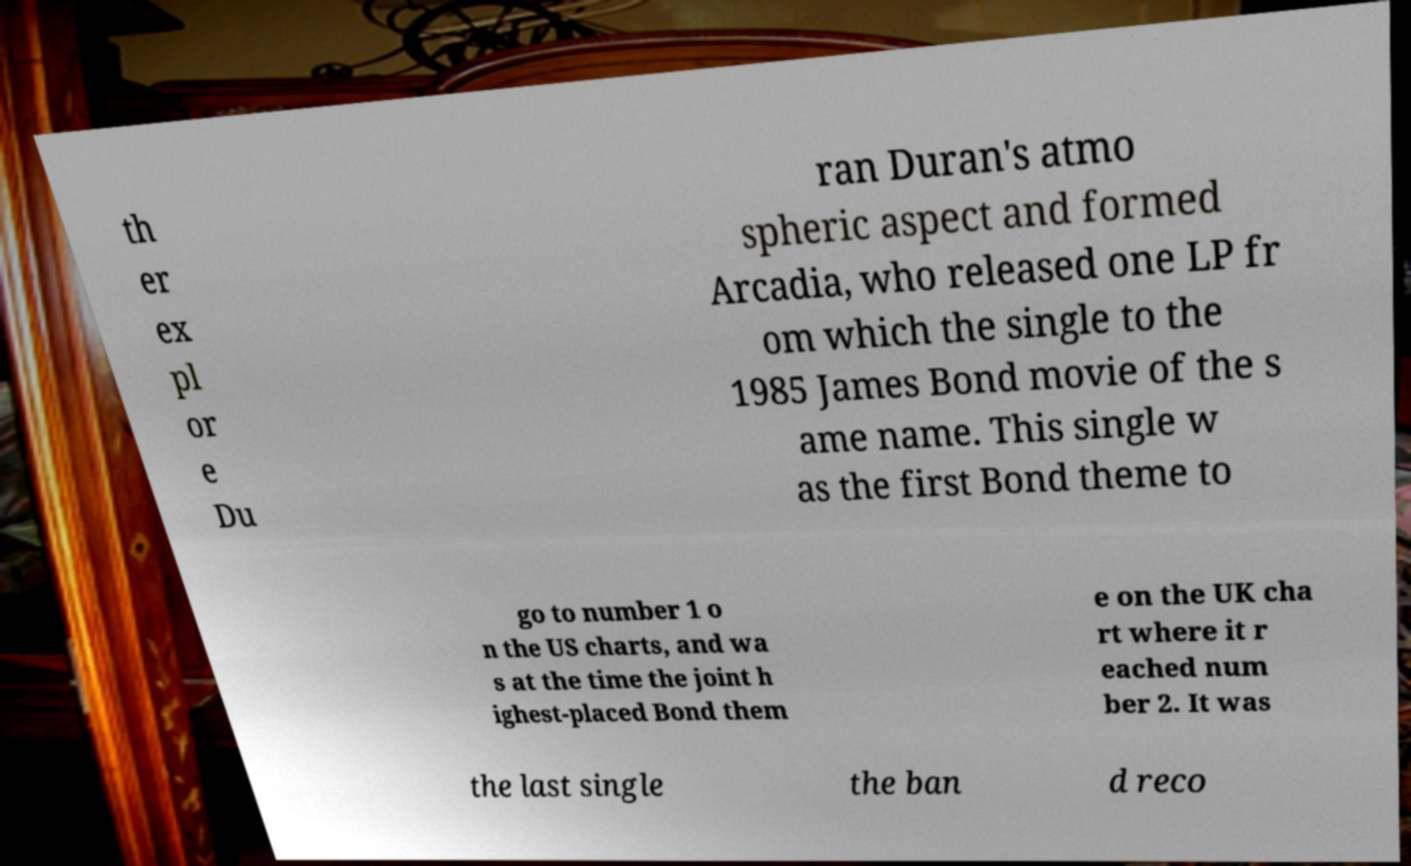Can you read and provide the text displayed in the image?This photo seems to have some interesting text. Can you extract and type it out for me? th er ex pl or e Du ran Duran's atmo spheric aspect and formed Arcadia, who released one LP fr om which the single to the 1985 James Bond movie of the s ame name. This single w as the first Bond theme to go to number 1 o n the US charts, and wa s at the time the joint h ighest-placed Bond them e on the UK cha rt where it r eached num ber 2. It was the last single the ban d reco 